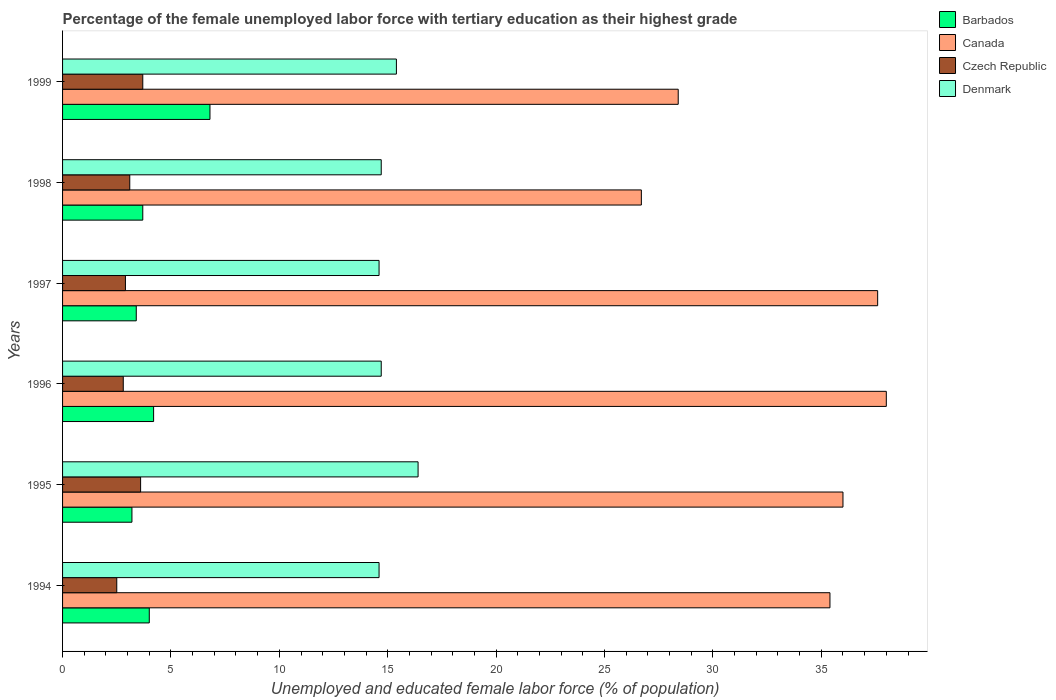Are the number of bars on each tick of the Y-axis equal?
Keep it short and to the point. Yes. What is the percentage of the unemployed female labor force with tertiary education in Canada in 1999?
Keep it short and to the point. 28.4. Across all years, what is the maximum percentage of the unemployed female labor force with tertiary education in Czech Republic?
Make the answer very short. 3.7. Across all years, what is the minimum percentage of the unemployed female labor force with tertiary education in Canada?
Keep it short and to the point. 26.7. What is the total percentage of the unemployed female labor force with tertiary education in Barbados in the graph?
Offer a very short reply. 25.3. What is the difference between the percentage of the unemployed female labor force with tertiary education in Czech Republic in 1994 and that in 1999?
Make the answer very short. -1.2. What is the difference between the percentage of the unemployed female labor force with tertiary education in Barbados in 1994 and the percentage of the unemployed female labor force with tertiary education in Czech Republic in 1996?
Offer a very short reply. 1.2. What is the average percentage of the unemployed female labor force with tertiary education in Czech Republic per year?
Ensure brevity in your answer.  3.1. In the year 1995, what is the difference between the percentage of the unemployed female labor force with tertiary education in Canada and percentage of the unemployed female labor force with tertiary education in Czech Republic?
Give a very brief answer. 32.4. What is the ratio of the percentage of the unemployed female labor force with tertiary education in Canada in 1996 to that in 1997?
Make the answer very short. 1.01. What is the difference between the highest and the second highest percentage of the unemployed female labor force with tertiary education in Canada?
Your answer should be very brief. 0.4. What is the difference between the highest and the lowest percentage of the unemployed female labor force with tertiary education in Czech Republic?
Provide a short and direct response. 1.2. In how many years, is the percentage of the unemployed female labor force with tertiary education in Czech Republic greater than the average percentage of the unemployed female labor force with tertiary education in Czech Republic taken over all years?
Keep it short and to the point. 2. Is the sum of the percentage of the unemployed female labor force with tertiary education in Czech Republic in 1994 and 1996 greater than the maximum percentage of the unemployed female labor force with tertiary education in Denmark across all years?
Provide a succinct answer. No. What does the 2nd bar from the top in 1997 represents?
Your response must be concise. Czech Republic. What does the 1st bar from the bottom in 1994 represents?
Give a very brief answer. Barbados. How many bars are there?
Provide a succinct answer. 24. Are all the bars in the graph horizontal?
Give a very brief answer. Yes. How many years are there in the graph?
Offer a terse response. 6. What is the difference between two consecutive major ticks on the X-axis?
Offer a very short reply. 5. Are the values on the major ticks of X-axis written in scientific E-notation?
Your response must be concise. No. What is the title of the graph?
Your answer should be compact. Percentage of the female unemployed labor force with tertiary education as their highest grade. Does "European Union" appear as one of the legend labels in the graph?
Provide a short and direct response. No. What is the label or title of the X-axis?
Your answer should be compact. Unemployed and educated female labor force (% of population). What is the Unemployed and educated female labor force (% of population) in Barbados in 1994?
Your answer should be compact. 4. What is the Unemployed and educated female labor force (% of population) in Canada in 1994?
Give a very brief answer. 35.4. What is the Unemployed and educated female labor force (% of population) of Czech Republic in 1994?
Offer a very short reply. 2.5. What is the Unemployed and educated female labor force (% of population) of Denmark in 1994?
Provide a short and direct response. 14.6. What is the Unemployed and educated female labor force (% of population) in Barbados in 1995?
Provide a short and direct response. 3.2. What is the Unemployed and educated female labor force (% of population) in Czech Republic in 1995?
Your answer should be very brief. 3.6. What is the Unemployed and educated female labor force (% of population) of Denmark in 1995?
Offer a terse response. 16.4. What is the Unemployed and educated female labor force (% of population) in Barbados in 1996?
Keep it short and to the point. 4.2. What is the Unemployed and educated female labor force (% of population) in Canada in 1996?
Give a very brief answer. 38. What is the Unemployed and educated female labor force (% of population) of Czech Republic in 1996?
Offer a terse response. 2.8. What is the Unemployed and educated female labor force (% of population) in Denmark in 1996?
Offer a very short reply. 14.7. What is the Unemployed and educated female labor force (% of population) in Barbados in 1997?
Give a very brief answer. 3.4. What is the Unemployed and educated female labor force (% of population) in Canada in 1997?
Provide a succinct answer. 37.6. What is the Unemployed and educated female labor force (% of population) in Czech Republic in 1997?
Offer a terse response. 2.9. What is the Unemployed and educated female labor force (% of population) of Denmark in 1997?
Keep it short and to the point. 14.6. What is the Unemployed and educated female labor force (% of population) of Barbados in 1998?
Offer a very short reply. 3.7. What is the Unemployed and educated female labor force (% of population) in Canada in 1998?
Your answer should be very brief. 26.7. What is the Unemployed and educated female labor force (% of population) in Czech Republic in 1998?
Ensure brevity in your answer.  3.1. What is the Unemployed and educated female labor force (% of population) in Denmark in 1998?
Ensure brevity in your answer.  14.7. What is the Unemployed and educated female labor force (% of population) in Barbados in 1999?
Your response must be concise. 6.8. What is the Unemployed and educated female labor force (% of population) of Canada in 1999?
Make the answer very short. 28.4. What is the Unemployed and educated female labor force (% of population) in Czech Republic in 1999?
Keep it short and to the point. 3.7. What is the Unemployed and educated female labor force (% of population) of Denmark in 1999?
Ensure brevity in your answer.  15.4. Across all years, what is the maximum Unemployed and educated female labor force (% of population) in Barbados?
Ensure brevity in your answer.  6.8. Across all years, what is the maximum Unemployed and educated female labor force (% of population) of Canada?
Provide a short and direct response. 38. Across all years, what is the maximum Unemployed and educated female labor force (% of population) of Czech Republic?
Keep it short and to the point. 3.7. Across all years, what is the maximum Unemployed and educated female labor force (% of population) in Denmark?
Your answer should be very brief. 16.4. Across all years, what is the minimum Unemployed and educated female labor force (% of population) of Barbados?
Ensure brevity in your answer.  3.2. Across all years, what is the minimum Unemployed and educated female labor force (% of population) in Canada?
Offer a very short reply. 26.7. Across all years, what is the minimum Unemployed and educated female labor force (% of population) of Czech Republic?
Your response must be concise. 2.5. Across all years, what is the minimum Unemployed and educated female labor force (% of population) of Denmark?
Make the answer very short. 14.6. What is the total Unemployed and educated female labor force (% of population) in Barbados in the graph?
Provide a succinct answer. 25.3. What is the total Unemployed and educated female labor force (% of population) in Canada in the graph?
Your answer should be compact. 202.1. What is the total Unemployed and educated female labor force (% of population) in Czech Republic in the graph?
Keep it short and to the point. 18.6. What is the total Unemployed and educated female labor force (% of population) of Denmark in the graph?
Make the answer very short. 90.4. What is the difference between the Unemployed and educated female labor force (% of population) in Denmark in 1994 and that in 1995?
Your answer should be very brief. -1.8. What is the difference between the Unemployed and educated female labor force (% of population) of Barbados in 1994 and that in 1996?
Provide a succinct answer. -0.2. What is the difference between the Unemployed and educated female labor force (% of population) of Canada in 1994 and that in 1996?
Keep it short and to the point. -2.6. What is the difference between the Unemployed and educated female labor force (% of population) of Czech Republic in 1994 and that in 1996?
Ensure brevity in your answer.  -0.3. What is the difference between the Unemployed and educated female labor force (% of population) in Canada in 1994 and that in 1997?
Provide a succinct answer. -2.2. What is the difference between the Unemployed and educated female labor force (% of population) of Czech Republic in 1994 and that in 1997?
Your answer should be very brief. -0.4. What is the difference between the Unemployed and educated female labor force (% of population) in Barbados in 1994 and that in 1998?
Ensure brevity in your answer.  0.3. What is the difference between the Unemployed and educated female labor force (% of population) of Czech Republic in 1994 and that in 1998?
Offer a very short reply. -0.6. What is the difference between the Unemployed and educated female labor force (% of population) of Canada in 1994 and that in 1999?
Your answer should be compact. 7. What is the difference between the Unemployed and educated female labor force (% of population) of Denmark in 1994 and that in 1999?
Give a very brief answer. -0.8. What is the difference between the Unemployed and educated female labor force (% of population) in Barbados in 1995 and that in 1996?
Your answer should be compact. -1. What is the difference between the Unemployed and educated female labor force (% of population) in Canada in 1995 and that in 1996?
Provide a short and direct response. -2. What is the difference between the Unemployed and educated female labor force (% of population) of Denmark in 1995 and that in 1996?
Make the answer very short. 1.7. What is the difference between the Unemployed and educated female labor force (% of population) in Canada in 1995 and that in 1997?
Offer a terse response. -1.6. What is the difference between the Unemployed and educated female labor force (% of population) in Canada in 1995 and that in 1998?
Keep it short and to the point. 9.3. What is the difference between the Unemployed and educated female labor force (% of population) in Denmark in 1995 and that in 1998?
Keep it short and to the point. 1.7. What is the difference between the Unemployed and educated female labor force (% of population) of Barbados in 1995 and that in 1999?
Give a very brief answer. -3.6. What is the difference between the Unemployed and educated female labor force (% of population) of Canada in 1995 and that in 1999?
Give a very brief answer. 7.6. What is the difference between the Unemployed and educated female labor force (% of population) of Czech Republic in 1995 and that in 1999?
Make the answer very short. -0.1. What is the difference between the Unemployed and educated female labor force (% of population) of Denmark in 1995 and that in 1999?
Offer a terse response. 1. What is the difference between the Unemployed and educated female labor force (% of population) in Canada in 1996 and that in 1997?
Make the answer very short. 0.4. What is the difference between the Unemployed and educated female labor force (% of population) of Czech Republic in 1996 and that in 1997?
Offer a terse response. -0.1. What is the difference between the Unemployed and educated female labor force (% of population) of Denmark in 1996 and that in 1997?
Offer a very short reply. 0.1. What is the difference between the Unemployed and educated female labor force (% of population) of Barbados in 1996 and that in 1998?
Make the answer very short. 0.5. What is the difference between the Unemployed and educated female labor force (% of population) of Czech Republic in 1996 and that in 1998?
Your answer should be very brief. -0.3. What is the difference between the Unemployed and educated female labor force (% of population) in Czech Republic in 1996 and that in 1999?
Your answer should be compact. -0.9. What is the difference between the Unemployed and educated female labor force (% of population) in Denmark in 1996 and that in 1999?
Provide a short and direct response. -0.7. What is the difference between the Unemployed and educated female labor force (% of population) of Barbados in 1997 and that in 1999?
Give a very brief answer. -3.4. What is the difference between the Unemployed and educated female labor force (% of population) of Canada in 1997 and that in 1999?
Provide a short and direct response. 9.2. What is the difference between the Unemployed and educated female labor force (% of population) in Denmark in 1997 and that in 1999?
Offer a terse response. -0.8. What is the difference between the Unemployed and educated female labor force (% of population) in Canada in 1998 and that in 1999?
Offer a terse response. -1.7. What is the difference between the Unemployed and educated female labor force (% of population) in Czech Republic in 1998 and that in 1999?
Offer a terse response. -0.6. What is the difference between the Unemployed and educated female labor force (% of population) of Barbados in 1994 and the Unemployed and educated female labor force (% of population) of Canada in 1995?
Keep it short and to the point. -32. What is the difference between the Unemployed and educated female labor force (% of population) of Barbados in 1994 and the Unemployed and educated female labor force (% of population) of Czech Republic in 1995?
Provide a succinct answer. 0.4. What is the difference between the Unemployed and educated female labor force (% of population) of Canada in 1994 and the Unemployed and educated female labor force (% of population) of Czech Republic in 1995?
Ensure brevity in your answer.  31.8. What is the difference between the Unemployed and educated female labor force (% of population) in Canada in 1994 and the Unemployed and educated female labor force (% of population) in Denmark in 1995?
Your answer should be compact. 19. What is the difference between the Unemployed and educated female labor force (% of population) in Barbados in 1994 and the Unemployed and educated female labor force (% of population) in Canada in 1996?
Your answer should be very brief. -34. What is the difference between the Unemployed and educated female labor force (% of population) of Barbados in 1994 and the Unemployed and educated female labor force (% of population) of Czech Republic in 1996?
Provide a succinct answer. 1.2. What is the difference between the Unemployed and educated female labor force (% of population) in Barbados in 1994 and the Unemployed and educated female labor force (% of population) in Denmark in 1996?
Make the answer very short. -10.7. What is the difference between the Unemployed and educated female labor force (% of population) of Canada in 1994 and the Unemployed and educated female labor force (% of population) of Czech Republic in 1996?
Give a very brief answer. 32.6. What is the difference between the Unemployed and educated female labor force (% of population) of Canada in 1994 and the Unemployed and educated female labor force (% of population) of Denmark in 1996?
Keep it short and to the point. 20.7. What is the difference between the Unemployed and educated female labor force (% of population) in Czech Republic in 1994 and the Unemployed and educated female labor force (% of population) in Denmark in 1996?
Provide a succinct answer. -12.2. What is the difference between the Unemployed and educated female labor force (% of population) in Barbados in 1994 and the Unemployed and educated female labor force (% of population) in Canada in 1997?
Offer a terse response. -33.6. What is the difference between the Unemployed and educated female labor force (% of population) in Barbados in 1994 and the Unemployed and educated female labor force (% of population) in Czech Republic in 1997?
Your answer should be very brief. 1.1. What is the difference between the Unemployed and educated female labor force (% of population) in Canada in 1994 and the Unemployed and educated female labor force (% of population) in Czech Republic in 1997?
Offer a very short reply. 32.5. What is the difference between the Unemployed and educated female labor force (% of population) in Canada in 1994 and the Unemployed and educated female labor force (% of population) in Denmark in 1997?
Offer a very short reply. 20.8. What is the difference between the Unemployed and educated female labor force (% of population) of Barbados in 1994 and the Unemployed and educated female labor force (% of population) of Canada in 1998?
Offer a very short reply. -22.7. What is the difference between the Unemployed and educated female labor force (% of population) of Canada in 1994 and the Unemployed and educated female labor force (% of population) of Czech Republic in 1998?
Offer a very short reply. 32.3. What is the difference between the Unemployed and educated female labor force (% of population) of Canada in 1994 and the Unemployed and educated female labor force (% of population) of Denmark in 1998?
Your answer should be compact. 20.7. What is the difference between the Unemployed and educated female labor force (% of population) in Czech Republic in 1994 and the Unemployed and educated female labor force (% of population) in Denmark in 1998?
Your response must be concise. -12.2. What is the difference between the Unemployed and educated female labor force (% of population) of Barbados in 1994 and the Unemployed and educated female labor force (% of population) of Canada in 1999?
Provide a short and direct response. -24.4. What is the difference between the Unemployed and educated female labor force (% of population) of Canada in 1994 and the Unemployed and educated female labor force (% of population) of Czech Republic in 1999?
Your response must be concise. 31.7. What is the difference between the Unemployed and educated female labor force (% of population) of Czech Republic in 1994 and the Unemployed and educated female labor force (% of population) of Denmark in 1999?
Provide a short and direct response. -12.9. What is the difference between the Unemployed and educated female labor force (% of population) of Barbados in 1995 and the Unemployed and educated female labor force (% of population) of Canada in 1996?
Offer a very short reply. -34.8. What is the difference between the Unemployed and educated female labor force (% of population) of Barbados in 1995 and the Unemployed and educated female labor force (% of population) of Denmark in 1996?
Your answer should be compact. -11.5. What is the difference between the Unemployed and educated female labor force (% of population) in Canada in 1995 and the Unemployed and educated female labor force (% of population) in Czech Republic in 1996?
Keep it short and to the point. 33.2. What is the difference between the Unemployed and educated female labor force (% of population) of Canada in 1995 and the Unemployed and educated female labor force (% of population) of Denmark in 1996?
Provide a short and direct response. 21.3. What is the difference between the Unemployed and educated female labor force (% of population) of Barbados in 1995 and the Unemployed and educated female labor force (% of population) of Canada in 1997?
Offer a very short reply. -34.4. What is the difference between the Unemployed and educated female labor force (% of population) in Barbados in 1995 and the Unemployed and educated female labor force (% of population) in Czech Republic in 1997?
Ensure brevity in your answer.  0.3. What is the difference between the Unemployed and educated female labor force (% of population) in Canada in 1995 and the Unemployed and educated female labor force (% of population) in Czech Republic in 1997?
Your answer should be compact. 33.1. What is the difference between the Unemployed and educated female labor force (% of population) of Canada in 1995 and the Unemployed and educated female labor force (% of population) of Denmark in 1997?
Your response must be concise. 21.4. What is the difference between the Unemployed and educated female labor force (% of population) in Czech Republic in 1995 and the Unemployed and educated female labor force (% of population) in Denmark in 1997?
Your response must be concise. -11. What is the difference between the Unemployed and educated female labor force (% of population) of Barbados in 1995 and the Unemployed and educated female labor force (% of population) of Canada in 1998?
Make the answer very short. -23.5. What is the difference between the Unemployed and educated female labor force (% of population) in Barbados in 1995 and the Unemployed and educated female labor force (% of population) in Denmark in 1998?
Give a very brief answer. -11.5. What is the difference between the Unemployed and educated female labor force (% of population) in Canada in 1995 and the Unemployed and educated female labor force (% of population) in Czech Republic in 1998?
Your response must be concise. 32.9. What is the difference between the Unemployed and educated female labor force (% of population) of Canada in 1995 and the Unemployed and educated female labor force (% of population) of Denmark in 1998?
Make the answer very short. 21.3. What is the difference between the Unemployed and educated female labor force (% of population) of Barbados in 1995 and the Unemployed and educated female labor force (% of population) of Canada in 1999?
Make the answer very short. -25.2. What is the difference between the Unemployed and educated female labor force (% of population) in Barbados in 1995 and the Unemployed and educated female labor force (% of population) in Czech Republic in 1999?
Your answer should be compact. -0.5. What is the difference between the Unemployed and educated female labor force (% of population) in Canada in 1995 and the Unemployed and educated female labor force (% of population) in Czech Republic in 1999?
Keep it short and to the point. 32.3. What is the difference between the Unemployed and educated female labor force (% of population) of Canada in 1995 and the Unemployed and educated female labor force (% of population) of Denmark in 1999?
Give a very brief answer. 20.6. What is the difference between the Unemployed and educated female labor force (% of population) in Barbados in 1996 and the Unemployed and educated female labor force (% of population) in Canada in 1997?
Keep it short and to the point. -33.4. What is the difference between the Unemployed and educated female labor force (% of population) in Barbados in 1996 and the Unemployed and educated female labor force (% of population) in Denmark in 1997?
Provide a short and direct response. -10.4. What is the difference between the Unemployed and educated female labor force (% of population) of Canada in 1996 and the Unemployed and educated female labor force (% of population) of Czech Republic in 1997?
Ensure brevity in your answer.  35.1. What is the difference between the Unemployed and educated female labor force (% of population) of Canada in 1996 and the Unemployed and educated female labor force (% of population) of Denmark in 1997?
Make the answer very short. 23.4. What is the difference between the Unemployed and educated female labor force (% of population) in Czech Republic in 1996 and the Unemployed and educated female labor force (% of population) in Denmark in 1997?
Your answer should be compact. -11.8. What is the difference between the Unemployed and educated female labor force (% of population) in Barbados in 1996 and the Unemployed and educated female labor force (% of population) in Canada in 1998?
Your answer should be compact. -22.5. What is the difference between the Unemployed and educated female labor force (% of population) in Barbados in 1996 and the Unemployed and educated female labor force (% of population) in Czech Republic in 1998?
Your answer should be very brief. 1.1. What is the difference between the Unemployed and educated female labor force (% of population) of Barbados in 1996 and the Unemployed and educated female labor force (% of population) of Denmark in 1998?
Offer a very short reply. -10.5. What is the difference between the Unemployed and educated female labor force (% of population) in Canada in 1996 and the Unemployed and educated female labor force (% of population) in Czech Republic in 1998?
Provide a short and direct response. 34.9. What is the difference between the Unemployed and educated female labor force (% of population) of Canada in 1996 and the Unemployed and educated female labor force (% of population) of Denmark in 1998?
Provide a succinct answer. 23.3. What is the difference between the Unemployed and educated female labor force (% of population) in Czech Republic in 1996 and the Unemployed and educated female labor force (% of population) in Denmark in 1998?
Offer a very short reply. -11.9. What is the difference between the Unemployed and educated female labor force (% of population) in Barbados in 1996 and the Unemployed and educated female labor force (% of population) in Canada in 1999?
Give a very brief answer. -24.2. What is the difference between the Unemployed and educated female labor force (% of population) of Canada in 1996 and the Unemployed and educated female labor force (% of population) of Czech Republic in 1999?
Your response must be concise. 34.3. What is the difference between the Unemployed and educated female labor force (% of population) of Canada in 1996 and the Unemployed and educated female labor force (% of population) of Denmark in 1999?
Provide a succinct answer. 22.6. What is the difference between the Unemployed and educated female labor force (% of population) in Czech Republic in 1996 and the Unemployed and educated female labor force (% of population) in Denmark in 1999?
Offer a very short reply. -12.6. What is the difference between the Unemployed and educated female labor force (% of population) of Barbados in 1997 and the Unemployed and educated female labor force (% of population) of Canada in 1998?
Your answer should be very brief. -23.3. What is the difference between the Unemployed and educated female labor force (% of population) of Canada in 1997 and the Unemployed and educated female labor force (% of population) of Czech Republic in 1998?
Provide a succinct answer. 34.5. What is the difference between the Unemployed and educated female labor force (% of population) in Canada in 1997 and the Unemployed and educated female labor force (% of population) in Denmark in 1998?
Your answer should be compact. 22.9. What is the difference between the Unemployed and educated female labor force (% of population) in Barbados in 1997 and the Unemployed and educated female labor force (% of population) in Denmark in 1999?
Give a very brief answer. -12. What is the difference between the Unemployed and educated female labor force (% of population) in Canada in 1997 and the Unemployed and educated female labor force (% of population) in Czech Republic in 1999?
Your answer should be compact. 33.9. What is the difference between the Unemployed and educated female labor force (% of population) in Barbados in 1998 and the Unemployed and educated female labor force (% of population) in Canada in 1999?
Your response must be concise. -24.7. What is the difference between the Unemployed and educated female labor force (% of population) in Barbados in 1998 and the Unemployed and educated female labor force (% of population) in Czech Republic in 1999?
Give a very brief answer. 0. What is the difference between the Unemployed and educated female labor force (% of population) of Barbados in 1998 and the Unemployed and educated female labor force (% of population) of Denmark in 1999?
Your answer should be very brief. -11.7. What is the difference between the Unemployed and educated female labor force (% of population) in Canada in 1998 and the Unemployed and educated female labor force (% of population) in Denmark in 1999?
Your response must be concise. 11.3. What is the difference between the Unemployed and educated female labor force (% of population) of Czech Republic in 1998 and the Unemployed and educated female labor force (% of population) of Denmark in 1999?
Make the answer very short. -12.3. What is the average Unemployed and educated female labor force (% of population) of Barbados per year?
Your response must be concise. 4.22. What is the average Unemployed and educated female labor force (% of population) in Canada per year?
Offer a terse response. 33.68. What is the average Unemployed and educated female labor force (% of population) of Czech Republic per year?
Give a very brief answer. 3.1. What is the average Unemployed and educated female labor force (% of population) in Denmark per year?
Your answer should be very brief. 15.07. In the year 1994, what is the difference between the Unemployed and educated female labor force (% of population) in Barbados and Unemployed and educated female labor force (% of population) in Canada?
Provide a succinct answer. -31.4. In the year 1994, what is the difference between the Unemployed and educated female labor force (% of population) of Barbados and Unemployed and educated female labor force (% of population) of Denmark?
Keep it short and to the point. -10.6. In the year 1994, what is the difference between the Unemployed and educated female labor force (% of population) of Canada and Unemployed and educated female labor force (% of population) of Czech Republic?
Offer a very short reply. 32.9. In the year 1994, what is the difference between the Unemployed and educated female labor force (% of population) in Canada and Unemployed and educated female labor force (% of population) in Denmark?
Make the answer very short. 20.8. In the year 1995, what is the difference between the Unemployed and educated female labor force (% of population) of Barbados and Unemployed and educated female labor force (% of population) of Canada?
Keep it short and to the point. -32.8. In the year 1995, what is the difference between the Unemployed and educated female labor force (% of population) of Barbados and Unemployed and educated female labor force (% of population) of Czech Republic?
Your answer should be compact. -0.4. In the year 1995, what is the difference between the Unemployed and educated female labor force (% of population) of Canada and Unemployed and educated female labor force (% of population) of Czech Republic?
Provide a short and direct response. 32.4. In the year 1995, what is the difference between the Unemployed and educated female labor force (% of population) in Canada and Unemployed and educated female labor force (% of population) in Denmark?
Your response must be concise. 19.6. In the year 1995, what is the difference between the Unemployed and educated female labor force (% of population) in Czech Republic and Unemployed and educated female labor force (% of population) in Denmark?
Your answer should be very brief. -12.8. In the year 1996, what is the difference between the Unemployed and educated female labor force (% of population) in Barbados and Unemployed and educated female labor force (% of population) in Canada?
Keep it short and to the point. -33.8. In the year 1996, what is the difference between the Unemployed and educated female labor force (% of population) of Barbados and Unemployed and educated female labor force (% of population) of Czech Republic?
Offer a terse response. 1.4. In the year 1996, what is the difference between the Unemployed and educated female labor force (% of population) in Barbados and Unemployed and educated female labor force (% of population) in Denmark?
Provide a succinct answer. -10.5. In the year 1996, what is the difference between the Unemployed and educated female labor force (% of population) of Canada and Unemployed and educated female labor force (% of population) of Czech Republic?
Offer a terse response. 35.2. In the year 1996, what is the difference between the Unemployed and educated female labor force (% of population) of Canada and Unemployed and educated female labor force (% of population) of Denmark?
Provide a short and direct response. 23.3. In the year 1996, what is the difference between the Unemployed and educated female labor force (% of population) of Czech Republic and Unemployed and educated female labor force (% of population) of Denmark?
Offer a terse response. -11.9. In the year 1997, what is the difference between the Unemployed and educated female labor force (% of population) of Barbados and Unemployed and educated female labor force (% of population) of Canada?
Your answer should be very brief. -34.2. In the year 1997, what is the difference between the Unemployed and educated female labor force (% of population) in Barbados and Unemployed and educated female labor force (% of population) in Czech Republic?
Make the answer very short. 0.5. In the year 1997, what is the difference between the Unemployed and educated female labor force (% of population) of Canada and Unemployed and educated female labor force (% of population) of Czech Republic?
Give a very brief answer. 34.7. In the year 1997, what is the difference between the Unemployed and educated female labor force (% of population) of Czech Republic and Unemployed and educated female labor force (% of population) of Denmark?
Keep it short and to the point. -11.7. In the year 1998, what is the difference between the Unemployed and educated female labor force (% of population) in Barbados and Unemployed and educated female labor force (% of population) in Canada?
Provide a short and direct response. -23. In the year 1998, what is the difference between the Unemployed and educated female labor force (% of population) of Barbados and Unemployed and educated female labor force (% of population) of Czech Republic?
Your answer should be compact. 0.6. In the year 1998, what is the difference between the Unemployed and educated female labor force (% of population) of Barbados and Unemployed and educated female labor force (% of population) of Denmark?
Your response must be concise. -11. In the year 1998, what is the difference between the Unemployed and educated female labor force (% of population) of Canada and Unemployed and educated female labor force (% of population) of Czech Republic?
Your answer should be very brief. 23.6. In the year 1998, what is the difference between the Unemployed and educated female labor force (% of population) in Canada and Unemployed and educated female labor force (% of population) in Denmark?
Make the answer very short. 12. In the year 1999, what is the difference between the Unemployed and educated female labor force (% of population) of Barbados and Unemployed and educated female labor force (% of population) of Canada?
Provide a short and direct response. -21.6. In the year 1999, what is the difference between the Unemployed and educated female labor force (% of population) of Barbados and Unemployed and educated female labor force (% of population) of Czech Republic?
Give a very brief answer. 3.1. In the year 1999, what is the difference between the Unemployed and educated female labor force (% of population) of Canada and Unemployed and educated female labor force (% of population) of Czech Republic?
Ensure brevity in your answer.  24.7. In the year 1999, what is the difference between the Unemployed and educated female labor force (% of population) of Canada and Unemployed and educated female labor force (% of population) of Denmark?
Provide a succinct answer. 13. In the year 1999, what is the difference between the Unemployed and educated female labor force (% of population) of Czech Republic and Unemployed and educated female labor force (% of population) of Denmark?
Offer a terse response. -11.7. What is the ratio of the Unemployed and educated female labor force (% of population) in Barbados in 1994 to that in 1995?
Provide a short and direct response. 1.25. What is the ratio of the Unemployed and educated female labor force (% of population) of Canada in 1994 to that in 1995?
Offer a terse response. 0.98. What is the ratio of the Unemployed and educated female labor force (% of population) in Czech Republic in 1994 to that in 1995?
Provide a succinct answer. 0.69. What is the ratio of the Unemployed and educated female labor force (% of population) of Denmark in 1994 to that in 1995?
Give a very brief answer. 0.89. What is the ratio of the Unemployed and educated female labor force (% of population) of Canada in 1994 to that in 1996?
Keep it short and to the point. 0.93. What is the ratio of the Unemployed and educated female labor force (% of population) in Czech Republic in 1994 to that in 1996?
Make the answer very short. 0.89. What is the ratio of the Unemployed and educated female labor force (% of population) of Denmark in 1994 to that in 1996?
Ensure brevity in your answer.  0.99. What is the ratio of the Unemployed and educated female labor force (% of population) in Barbados in 1994 to that in 1997?
Offer a terse response. 1.18. What is the ratio of the Unemployed and educated female labor force (% of population) in Canada in 1994 to that in 1997?
Make the answer very short. 0.94. What is the ratio of the Unemployed and educated female labor force (% of population) in Czech Republic in 1994 to that in 1997?
Offer a terse response. 0.86. What is the ratio of the Unemployed and educated female labor force (% of population) of Barbados in 1994 to that in 1998?
Offer a very short reply. 1.08. What is the ratio of the Unemployed and educated female labor force (% of population) in Canada in 1994 to that in 1998?
Make the answer very short. 1.33. What is the ratio of the Unemployed and educated female labor force (% of population) of Czech Republic in 1994 to that in 1998?
Your response must be concise. 0.81. What is the ratio of the Unemployed and educated female labor force (% of population) in Barbados in 1994 to that in 1999?
Provide a short and direct response. 0.59. What is the ratio of the Unemployed and educated female labor force (% of population) of Canada in 1994 to that in 1999?
Make the answer very short. 1.25. What is the ratio of the Unemployed and educated female labor force (% of population) of Czech Republic in 1994 to that in 1999?
Your answer should be compact. 0.68. What is the ratio of the Unemployed and educated female labor force (% of population) in Denmark in 1994 to that in 1999?
Provide a short and direct response. 0.95. What is the ratio of the Unemployed and educated female labor force (% of population) of Barbados in 1995 to that in 1996?
Keep it short and to the point. 0.76. What is the ratio of the Unemployed and educated female labor force (% of population) in Canada in 1995 to that in 1996?
Your answer should be very brief. 0.95. What is the ratio of the Unemployed and educated female labor force (% of population) in Czech Republic in 1995 to that in 1996?
Offer a terse response. 1.29. What is the ratio of the Unemployed and educated female labor force (% of population) in Denmark in 1995 to that in 1996?
Provide a succinct answer. 1.12. What is the ratio of the Unemployed and educated female labor force (% of population) in Canada in 1995 to that in 1997?
Your response must be concise. 0.96. What is the ratio of the Unemployed and educated female labor force (% of population) of Czech Republic in 1995 to that in 1997?
Your answer should be compact. 1.24. What is the ratio of the Unemployed and educated female labor force (% of population) in Denmark in 1995 to that in 1997?
Keep it short and to the point. 1.12. What is the ratio of the Unemployed and educated female labor force (% of population) in Barbados in 1995 to that in 1998?
Provide a succinct answer. 0.86. What is the ratio of the Unemployed and educated female labor force (% of population) in Canada in 1995 to that in 1998?
Your answer should be compact. 1.35. What is the ratio of the Unemployed and educated female labor force (% of population) of Czech Republic in 1995 to that in 1998?
Make the answer very short. 1.16. What is the ratio of the Unemployed and educated female labor force (% of population) in Denmark in 1995 to that in 1998?
Your answer should be very brief. 1.12. What is the ratio of the Unemployed and educated female labor force (% of population) of Barbados in 1995 to that in 1999?
Keep it short and to the point. 0.47. What is the ratio of the Unemployed and educated female labor force (% of population) of Canada in 1995 to that in 1999?
Your response must be concise. 1.27. What is the ratio of the Unemployed and educated female labor force (% of population) of Czech Republic in 1995 to that in 1999?
Offer a terse response. 0.97. What is the ratio of the Unemployed and educated female labor force (% of population) in Denmark in 1995 to that in 1999?
Keep it short and to the point. 1.06. What is the ratio of the Unemployed and educated female labor force (% of population) in Barbados in 1996 to that in 1997?
Make the answer very short. 1.24. What is the ratio of the Unemployed and educated female labor force (% of population) of Canada in 1996 to that in 1997?
Your response must be concise. 1.01. What is the ratio of the Unemployed and educated female labor force (% of population) of Czech Republic in 1996 to that in 1997?
Give a very brief answer. 0.97. What is the ratio of the Unemployed and educated female labor force (% of population) of Denmark in 1996 to that in 1997?
Your response must be concise. 1.01. What is the ratio of the Unemployed and educated female labor force (% of population) in Barbados in 1996 to that in 1998?
Offer a very short reply. 1.14. What is the ratio of the Unemployed and educated female labor force (% of population) in Canada in 1996 to that in 1998?
Your response must be concise. 1.42. What is the ratio of the Unemployed and educated female labor force (% of population) of Czech Republic in 1996 to that in 1998?
Your answer should be very brief. 0.9. What is the ratio of the Unemployed and educated female labor force (% of population) in Barbados in 1996 to that in 1999?
Your answer should be very brief. 0.62. What is the ratio of the Unemployed and educated female labor force (% of population) in Canada in 1996 to that in 1999?
Make the answer very short. 1.34. What is the ratio of the Unemployed and educated female labor force (% of population) in Czech Republic in 1996 to that in 1999?
Offer a terse response. 0.76. What is the ratio of the Unemployed and educated female labor force (% of population) in Denmark in 1996 to that in 1999?
Your answer should be compact. 0.95. What is the ratio of the Unemployed and educated female labor force (% of population) in Barbados in 1997 to that in 1998?
Your response must be concise. 0.92. What is the ratio of the Unemployed and educated female labor force (% of population) in Canada in 1997 to that in 1998?
Provide a short and direct response. 1.41. What is the ratio of the Unemployed and educated female labor force (% of population) in Czech Republic in 1997 to that in 1998?
Offer a very short reply. 0.94. What is the ratio of the Unemployed and educated female labor force (% of population) in Canada in 1997 to that in 1999?
Give a very brief answer. 1.32. What is the ratio of the Unemployed and educated female labor force (% of population) in Czech Republic in 1997 to that in 1999?
Your response must be concise. 0.78. What is the ratio of the Unemployed and educated female labor force (% of population) of Denmark in 1997 to that in 1999?
Keep it short and to the point. 0.95. What is the ratio of the Unemployed and educated female labor force (% of population) in Barbados in 1998 to that in 1999?
Offer a terse response. 0.54. What is the ratio of the Unemployed and educated female labor force (% of population) in Canada in 1998 to that in 1999?
Offer a terse response. 0.94. What is the ratio of the Unemployed and educated female labor force (% of population) in Czech Republic in 1998 to that in 1999?
Give a very brief answer. 0.84. What is the ratio of the Unemployed and educated female labor force (% of population) in Denmark in 1998 to that in 1999?
Your answer should be compact. 0.95. What is the difference between the highest and the second highest Unemployed and educated female labor force (% of population) in Barbados?
Your answer should be compact. 2.6. 